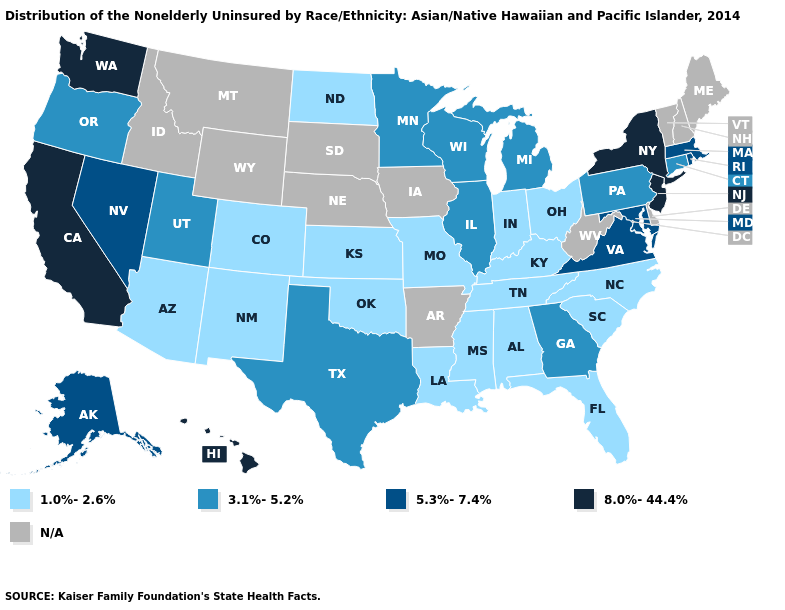What is the value of Mississippi?
Write a very short answer. 1.0%-2.6%. What is the lowest value in the USA?
Quick response, please. 1.0%-2.6%. Does the map have missing data?
Give a very brief answer. Yes. What is the value of Oregon?
Concise answer only. 3.1%-5.2%. What is the lowest value in states that border Maryland?
Give a very brief answer. 3.1%-5.2%. Does New Jersey have the highest value in the Northeast?
Concise answer only. Yes. Name the states that have a value in the range 3.1%-5.2%?
Be succinct. Connecticut, Georgia, Illinois, Michigan, Minnesota, Oregon, Pennsylvania, Texas, Utah, Wisconsin. Which states have the lowest value in the Northeast?
Give a very brief answer. Connecticut, Pennsylvania. What is the lowest value in the South?
Write a very short answer. 1.0%-2.6%. Is the legend a continuous bar?
Quick response, please. No. Which states hav the highest value in the South?
Answer briefly. Maryland, Virginia. What is the value of Georgia?
Answer briefly. 3.1%-5.2%. What is the value of Illinois?
Write a very short answer. 3.1%-5.2%. What is the value of Mississippi?
Quick response, please. 1.0%-2.6%. What is the value of Arkansas?
Keep it brief. N/A. 